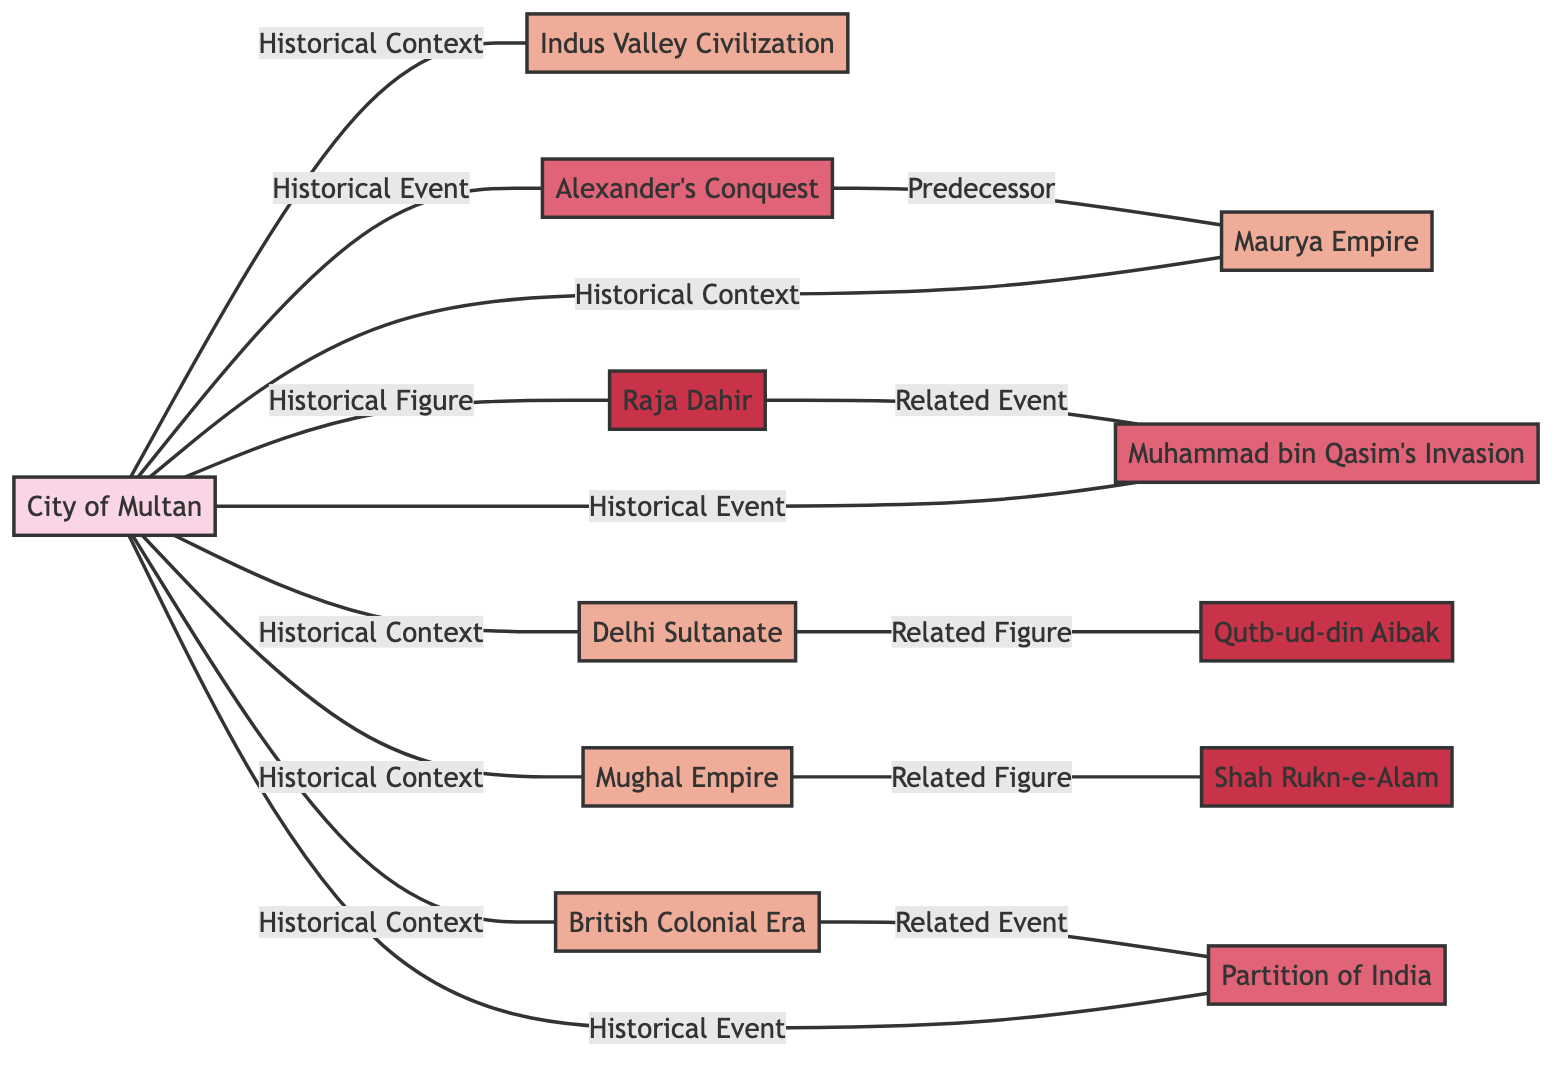What is the type of node representing the city of Multan? In the diagram, the node for the city of Multan is labeled as "City of Multan" and is categorized under the type "Location" as indicated by the use of specific styling for location nodes.
Answer: Location How many events are depicted in the network? By counting the nodes labeled as "Event," we find three events: "Alexander's Conquest," "Muhammad bin Qasim's Invasion," and "Partition of India." Thus, the number of events is three.
Answer: 3 Which figure is related to Muhammad bin Qasim's Invasion? The relationship is shown by the link that connects the node labeled "Raja Dahir" to "Muhammad bin Qasim's Invasion," indicating that Raja Dahir is a relevant figure related to this event.
Answer: Raja Dahir What era follows the event of Alexander's Conquest? The diagram delineates a direct predecessor relationship where "Alexander's Conquest" is linked to the "Maurya Empire," specifying that the Maurya Empire is the era that comes after the event of Alexander's Conquest.
Answer: Maurya Empire Which historical figure is associated with the Mughal Empire? The diagram shows a connection between the "Mughal Empire" and the figure "Shah Rukn-e-Alam," indicating that Shah Rukn-e-Alam is a historically significant figure associated with the Mughal Empire.
Answer: Shah Rukn-e-Alam What type of event is the Partition of India categorized under? The node labeled "Partition of India" is classified under the type "Event," as indicated by the specific styling given to event nodes, allowing us to categorize it accurately.
Answer: Event Which two eras are linked to the events related to the Delhi Sultanate? The diagram shows that the "Delhi Sultanate" era is linked to the related figure "Qutb-ud-din Aibak," meaning that the connections exist between these nodes under the category of historical events during that era.
Answer: Delhi Sultanate, Qutb-ud-din Aibak What is the historical context shared by the City of Multan with the Indus Valley Civilization? The diagram depicts a direct link between the "City of Multan" and "Indus Valley Civilization" as "Historical Context," suggesting that both share significant historical relevance within the timeline of Multan's history.
Answer: Historical Context 